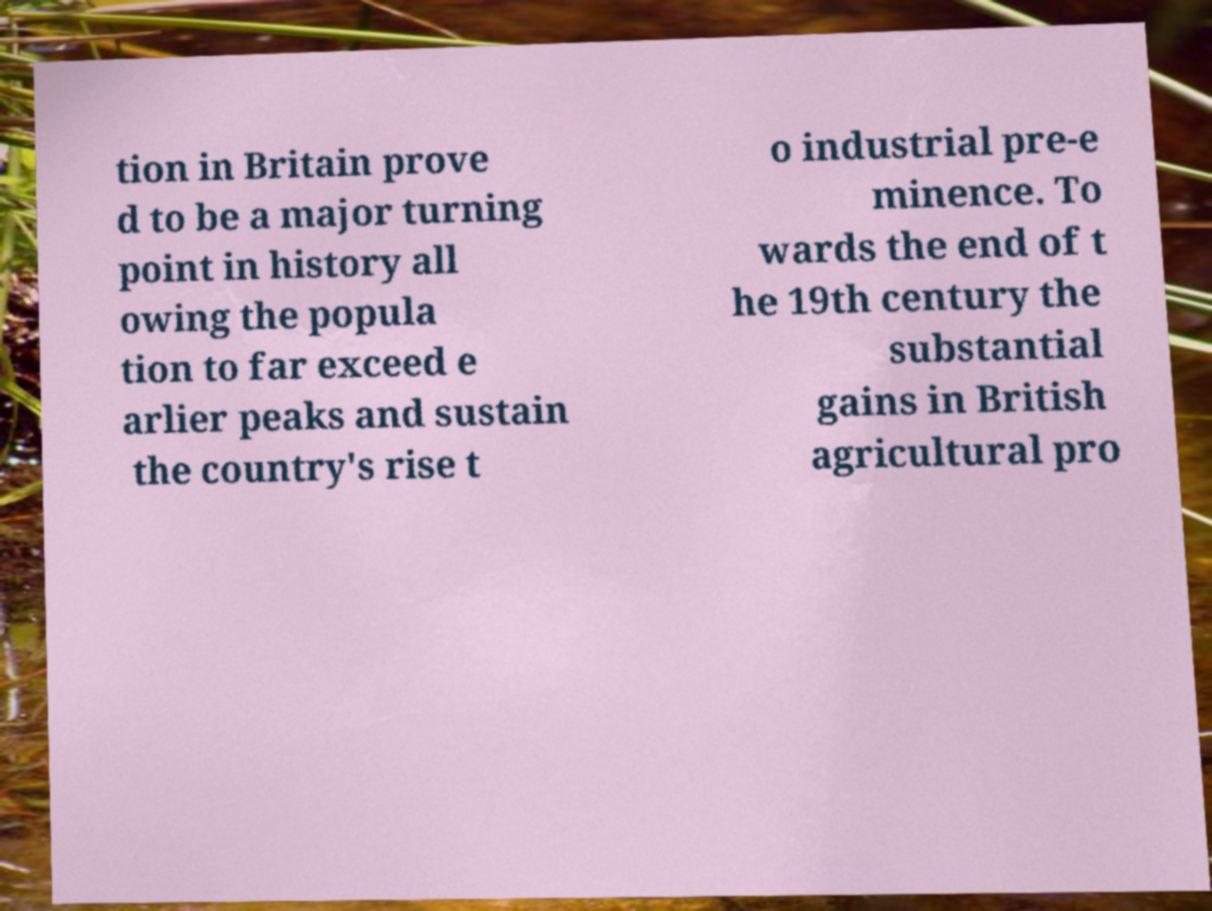Can you read and provide the text displayed in the image?This photo seems to have some interesting text. Can you extract and type it out for me? tion in Britain prove d to be a major turning point in history all owing the popula tion to far exceed e arlier peaks and sustain the country's rise t o industrial pre-e minence. To wards the end of t he 19th century the substantial gains in British agricultural pro 